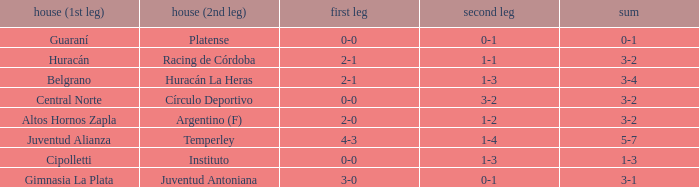Which team played the 2nd leg at home with a tie of 1-1 and scored 3-2 in aggregate? Racing de Córdoba. 